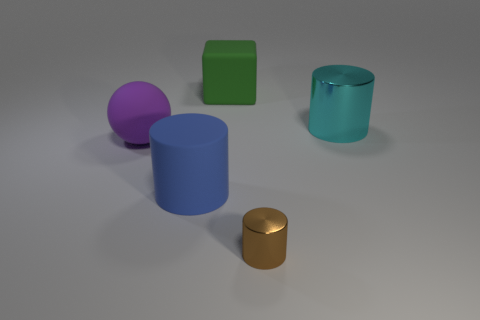Is there any other thing that has the same size as the brown cylinder?
Ensure brevity in your answer.  No. What is the big cylinder that is behind the large ball made of?
Your response must be concise. Metal. What shape is the purple thing behind the big cylinder to the left of the big cylinder to the right of the large cube?
Keep it short and to the point. Sphere. There is a thing behind the large cyan metal thing; does it have the same color as the shiny thing that is on the right side of the tiny brown metallic object?
Your answer should be very brief. No. Are there fewer purple matte objects that are in front of the brown shiny thing than metallic cylinders that are behind the purple rubber sphere?
Make the answer very short. Yes. Is there anything else that has the same shape as the big green thing?
Offer a terse response. No. There is a small metallic thing that is the same shape as the blue matte object; what color is it?
Provide a succinct answer. Brown. Is the shape of the brown object the same as the rubber thing that is to the right of the large blue rubber object?
Give a very brief answer. No. How many things are either large cylinders that are left of the brown metallic cylinder or rubber objects behind the large blue object?
Your answer should be compact. 3. What material is the brown thing?
Offer a terse response. Metal. 